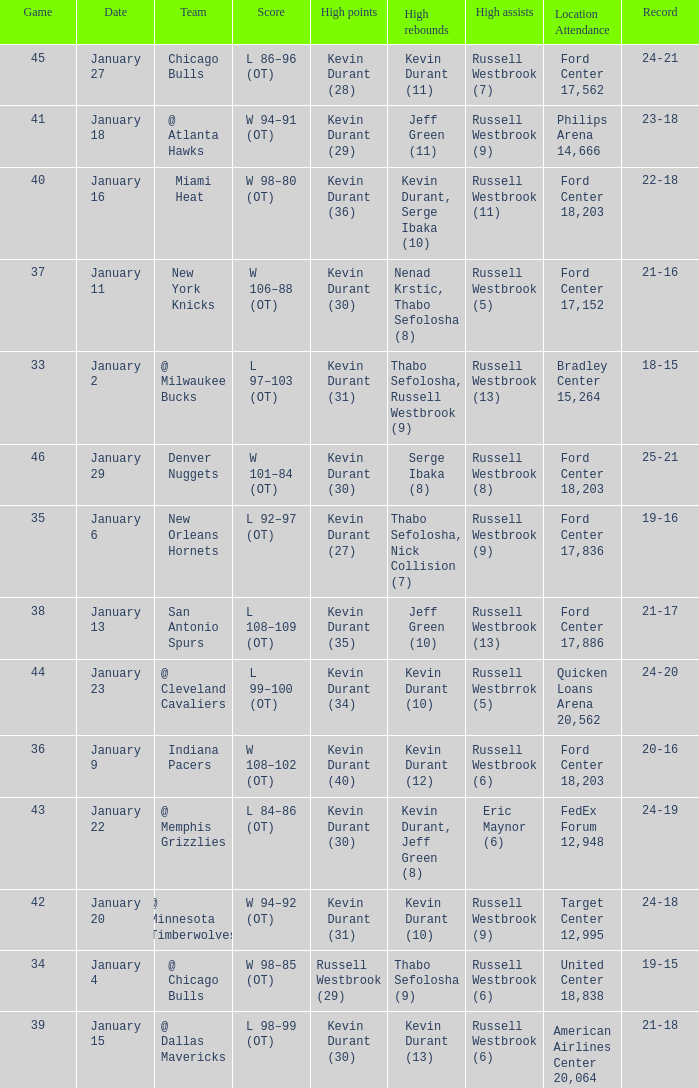Name the location attendance for january 18 Philips Arena 14,666. 